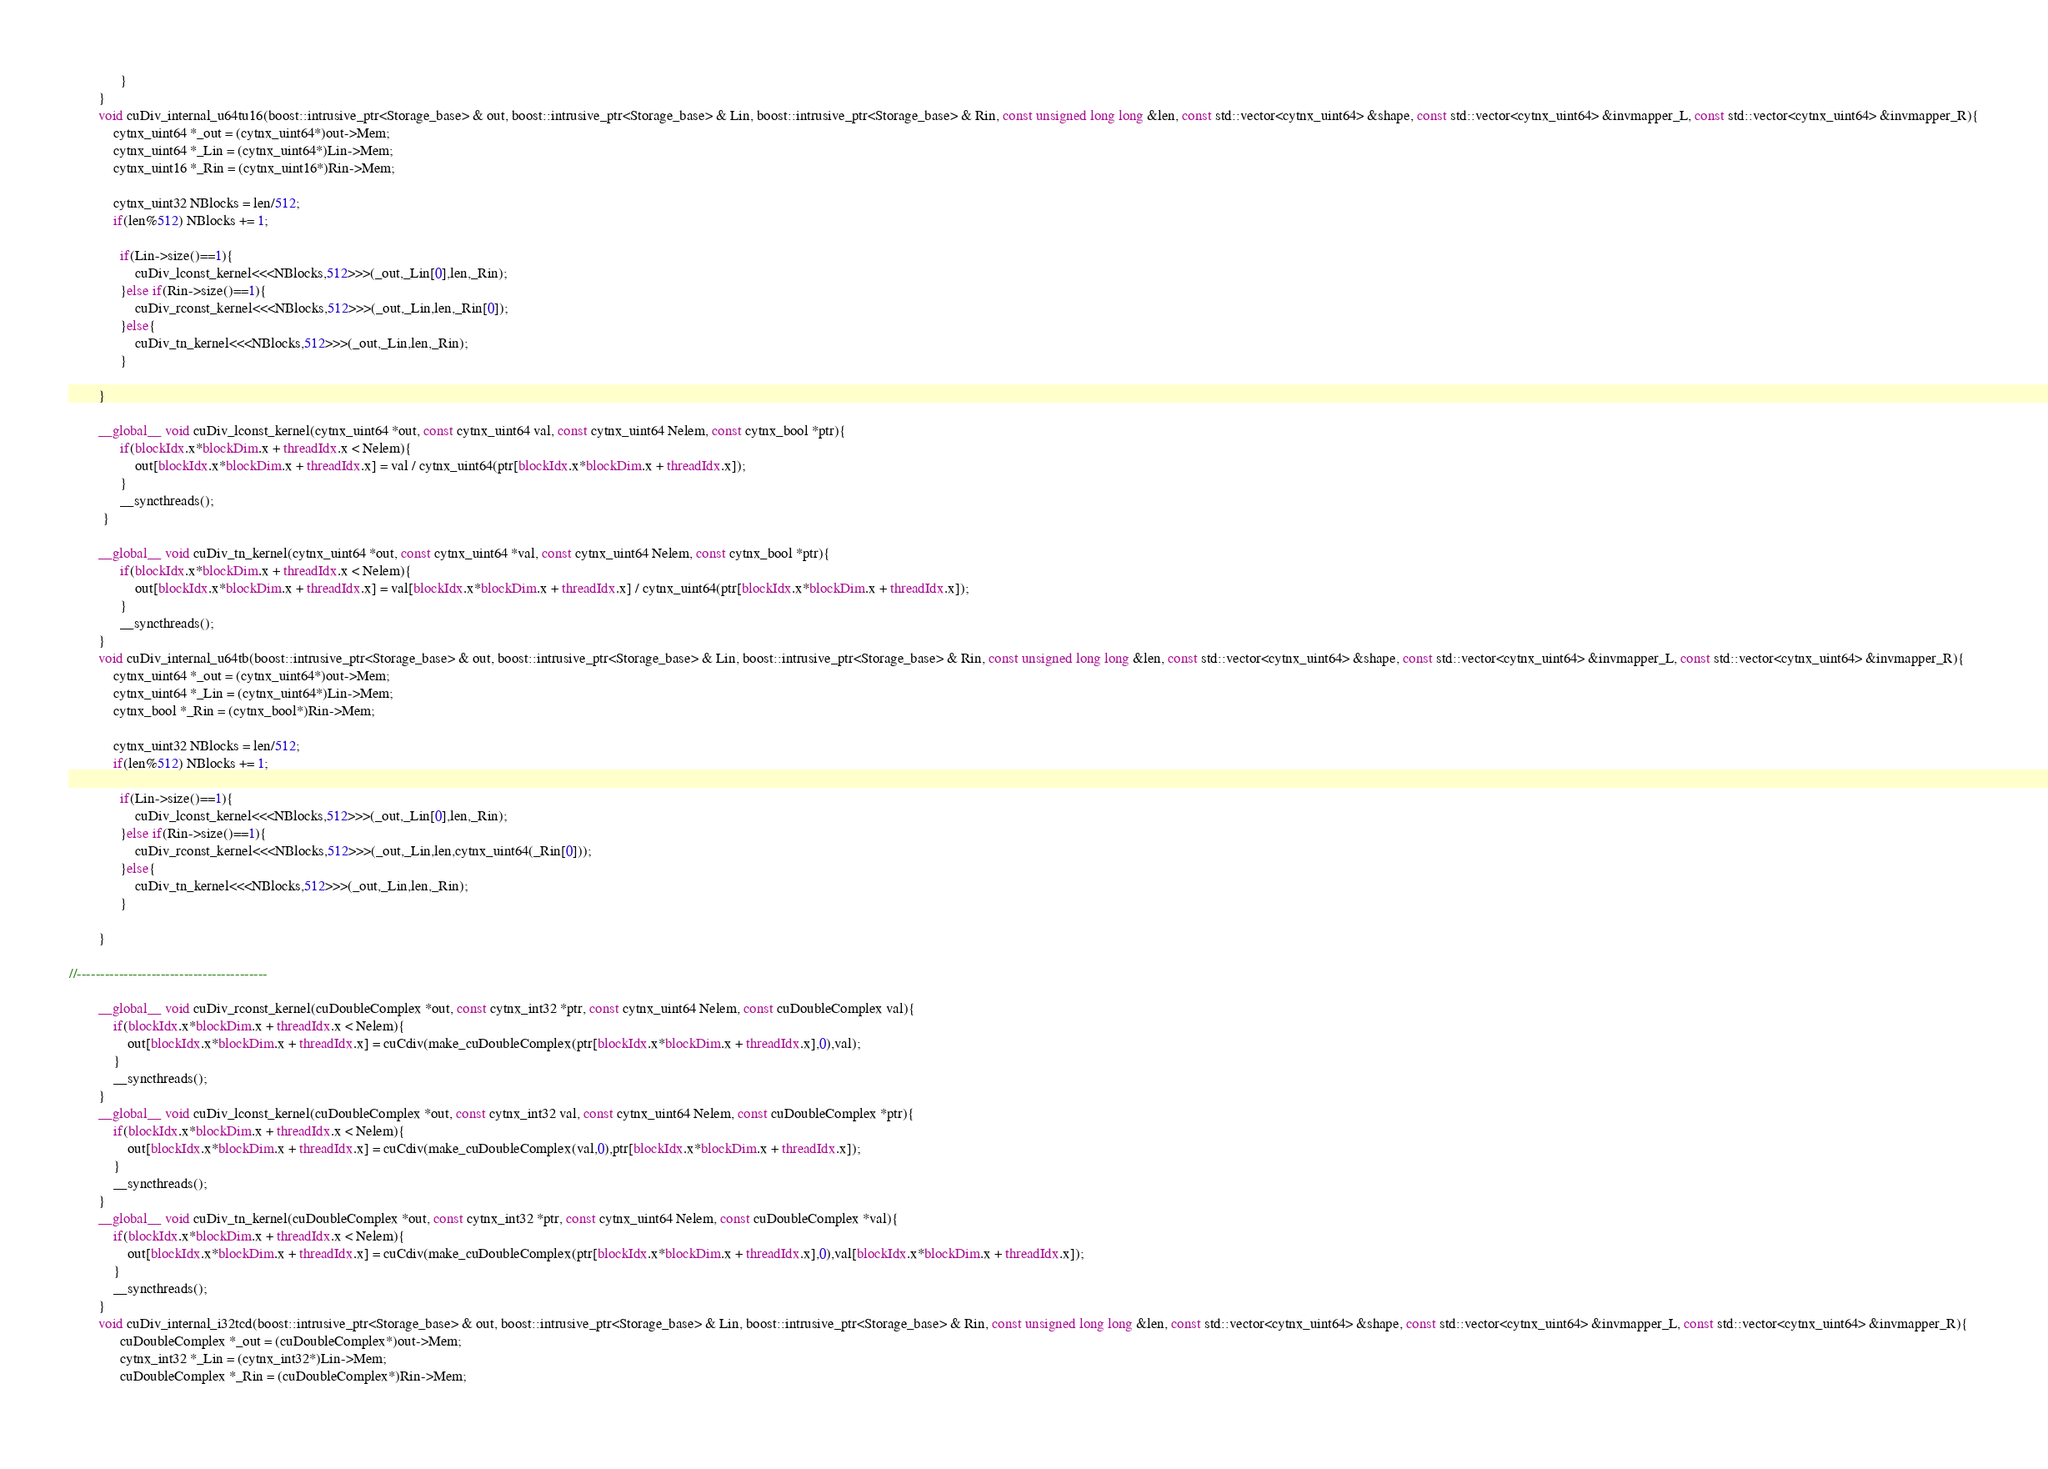Convert code to text. <code><loc_0><loc_0><loc_500><loc_500><_Cuda_>              }
        }
        void cuDiv_internal_u64tu16(boost::intrusive_ptr<Storage_base> & out, boost::intrusive_ptr<Storage_base> & Lin, boost::intrusive_ptr<Storage_base> & Rin, const unsigned long long &len, const std::vector<cytnx_uint64> &shape, const std::vector<cytnx_uint64> &invmapper_L, const std::vector<cytnx_uint64> &invmapper_R){
            cytnx_uint64 *_out = (cytnx_uint64*)out->Mem;
            cytnx_uint64 *_Lin = (cytnx_uint64*)Lin->Mem;
            cytnx_uint16 *_Rin = (cytnx_uint16*)Rin->Mem;

            cytnx_uint32 NBlocks = len/512;
            if(len%512) NBlocks += 1;

              if(Lin->size()==1){
                  cuDiv_lconst_kernel<<<NBlocks,512>>>(_out,_Lin[0],len,_Rin);
              }else if(Rin->size()==1){
                  cuDiv_rconst_kernel<<<NBlocks,512>>>(_out,_Lin,len,_Rin[0]);
              }else{
                  cuDiv_tn_kernel<<<NBlocks,512>>>(_out,_Lin,len,_Rin);
              }

        }

        __global__ void cuDiv_lconst_kernel(cytnx_uint64 *out, const cytnx_uint64 val, const cytnx_uint64 Nelem, const cytnx_bool *ptr){
              if(blockIdx.x*blockDim.x + threadIdx.x < Nelem){
                  out[blockIdx.x*blockDim.x + threadIdx.x] = val / cytnx_uint64(ptr[blockIdx.x*blockDim.x + threadIdx.x]);
              }
              __syncthreads();
         }
        
        __global__ void cuDiv_tn_kernel(cytnx_uint64 *out, const cytnx_uint64 *val, const cytnx_uint64 Nelem, const cytnx_bool *ptr){
              if(blockIdx.x*blockDim.x + threadIdx.x < Nelem){
                  out[blockIdx.x*blockDim.x + threadIdx.x] = val[blockIdx.x*blockDim.x + threadIdx.x] / cytnx_uint64(ptr[blockIdx.x*blockDim.x + threadIdx.x]);
              }
              __syncthreads();
        }
        void cuDiv_internal_u64tb(boost::intrusive_ptr<Storage_base> & out, boost::intrusive_ptr<Storage_base> & Lin, boost::intrusive_ptr<Storage_base> & Rin, const unsigned long long &len, const std::vector<cytnx_uint64> &shape, const std::vector<cytnx_uint64> &invmapper_L, const std::vector<cytnx_uint64> &invmapper_R){
            cytnx_uint64 *_out = (cytnx_uint64*)out->Mem;
            cytnx_uint64 *_Lin = (cytnx_uint64*)Lin->Mem;
            cytnx_bool *_Rin = (cytnx_bool*)Rin->Mem;

            cytnx_uint32 NBlocks = len/512;
            if(len%512) NBlocks += 1;

              if(Lin->size()==1){
                  cuDiv_lconst_kernel<<<NBlocks,512>>>(_out,_Lin[0],len,_Rin);
              }else if(Rin->size()==1){
                  cuDiv_rconst_kernel<<<NBlocks,512>>>(_out,_Lin,len,cytnx_uint64(_Rin[0]));
              }else{
                  cuDiv_tn_kernel<<<NBlocks,512>>>(_out,_Lin,len,_Rin);
              }

        }

//-----------------------------------------

        __global__ void cuDiv_rconst_kernel(cuDoubleComplex *out, const cytnx_int32 *ptr, const cytnx_uint64 Nelem, const cuDoubleComplex val){
            if(blockIdx.x*blockDim.x + threadIdx.x < Nelem){
                out[blockIdx.x*blockDim.x + threadIdx.x] = cuCdiv(make_cuDoubleComplex(ptr[blockIdx.x*blockDim.x + threadIdx.x],0),val);
            }
            __syncthreads();
        }
        __global__ void cuDiv_lconst_kernel(cuDoubleComplex *out, const cytnx_int32 val, const cytnx_uint64 Nelem, const cuDoubleComplex *ptr){
            if(blockIdx.x*blockDim.x + threadIdx.x < Nelem){
                out[blockIdx.x*blockDim.x + threadIdx.x] = cuCdiv(make_cuDoubleComplex(val,0),ptr[blockIdx.x*blockDim.x + threadIdx.x]);
            }
            __syncthreads();
        }
        __global__ void cuDiv_tn_kernel(cuDoubleComplex *out, const cytnx_int32 *ptr, const cytnx_uint64 Nelem, const cuDoubleComplex *val){
            if(blockIdx.x*blockDim.x + threadIdx.x < Nelem){
                out[blockIdx.x*blockDim.x + threadIdx.x] = cuCdiv(make_cuDoubleComplex(ptr[blockIdx.x*blockDim.x + threadIdx.x],0),val[blockIdx.x*blockDim.x + threadIdx.x]);
            }
            __syncthreads();
        }
        void cuDiv_internal_i32tcd(boost::intrusive_ptr<Storage_base> & out, boost::intrusive_ptr<Storage_base> & Lin, boost::intrusive_ptr<Storage_base> & Rin, const unsigned long long &len, const std::vector<cytnx_uint64> &shape, const std::vector<cytnx_uint64> &invmapper_L, const std::vector<cytnx_uint64> &invmapper_R){
              cuDoubleComplex *_out = (cuDoubleComplex*)out->Mem;
              cytnx_int32 *_Lin = (cytnx_int32*)Lin->Mem;
              cuDoubleComplex *_Rin = (cuDoubleComplex*)Rin->Mem;
  </code> 